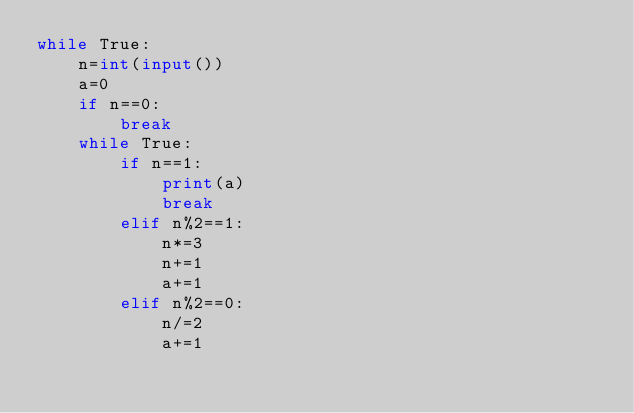<code> <loc_0><loc_0><loc_500><loc_500><_Python_>while True:
    n=int(input())
    a=0
    if n==0:
        break
    while True:
        if n==1:
            print(a)
            break
        elif n%2==1:
            n*=3
            n+=1
            a+=1
        elif n%2==0:
            n/=2
            a+=1
</code> 